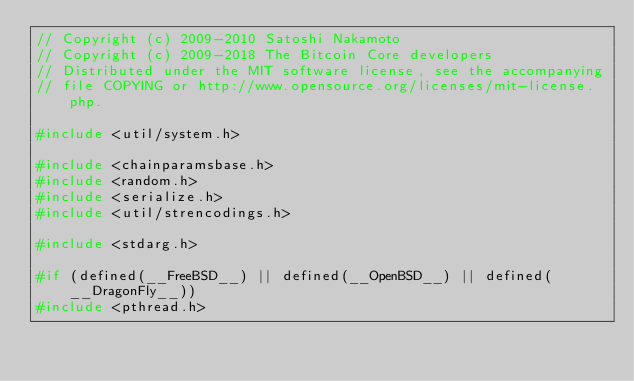<code> <loc_0><loc_0><loc_500><loc_500><_C++_>// Copyright (c) 2009-2010 Satoshi Nakamoto
// Copyright (c) 2009-2018 The Bitcoin Core developers
// Distributed under the MIT software license, see the accompanying
// file COPYING or http://www.opensource.org/licenses/mit-license.php.

#include <util/system.h>

#include <chainparamsbase.h>
#include <random.h>
#include <serialize.h>
#include <util/strencodings.h>

#include <stdarg.h>

#if (defined(__FreeBSD__) || defined(__OpenBSD__) || defined(__DragonFly__))
#include <pthread.h></code> 